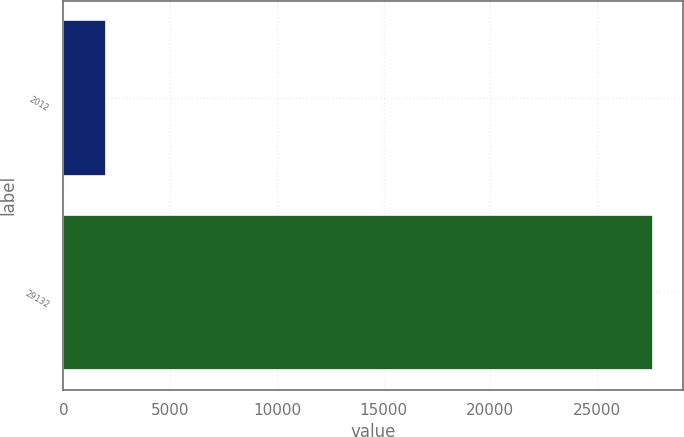Convert chart to OTSL. <chart><loc_0><loc_0><loc_500><loc_500><bar_chart><fcel>2012<fcel>29132<nl><fcel>2011<fcel>27634<nl></chart> 